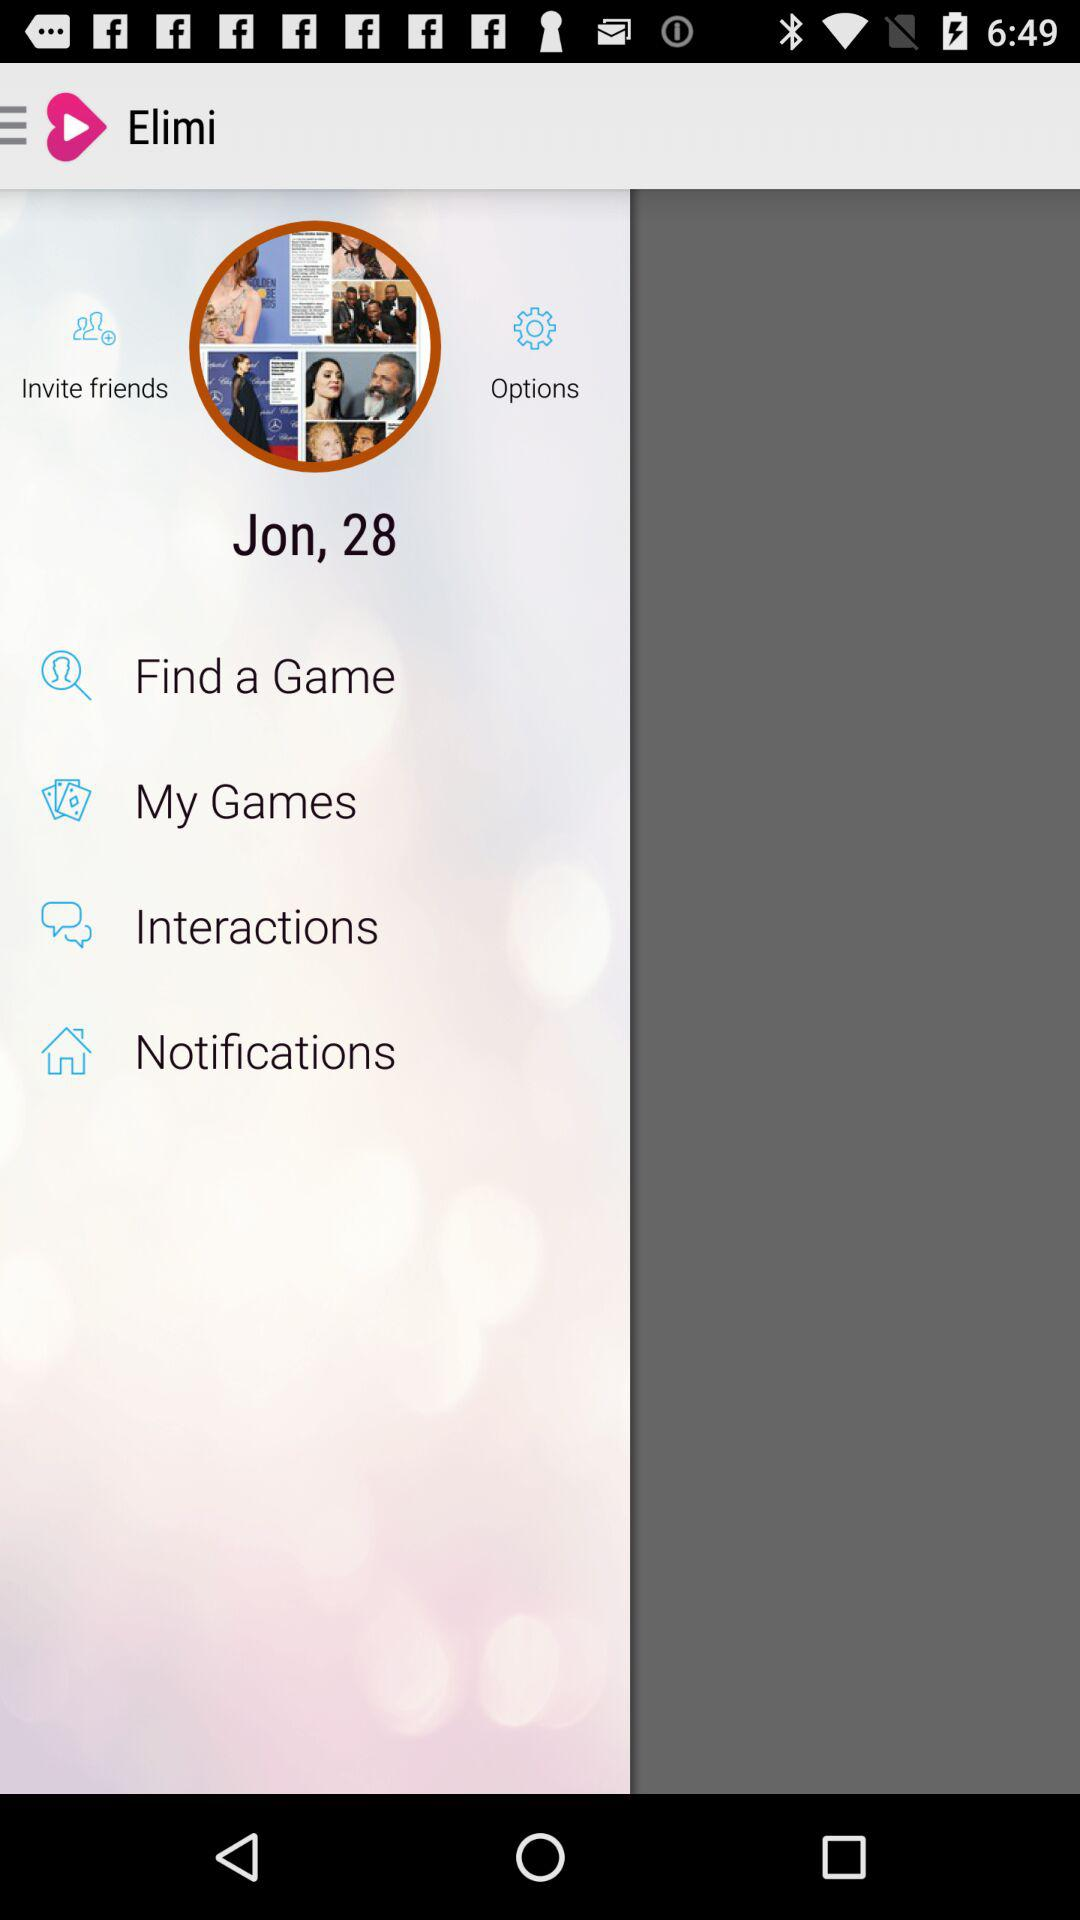What is the mentioned age? The mentioned age is 28. 